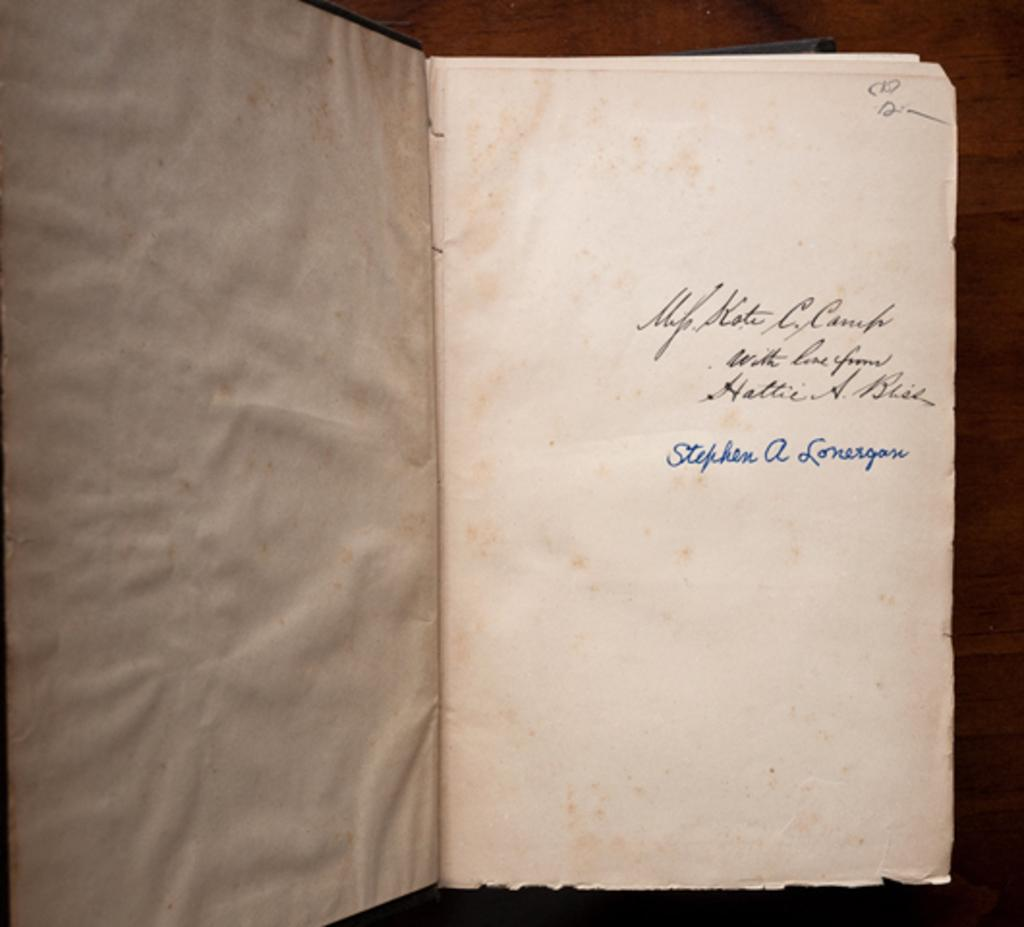<image>
Present a compact description of the photo's key features. The signature of Stephen A Lonergan is written in blue ink on the page of an old book. 